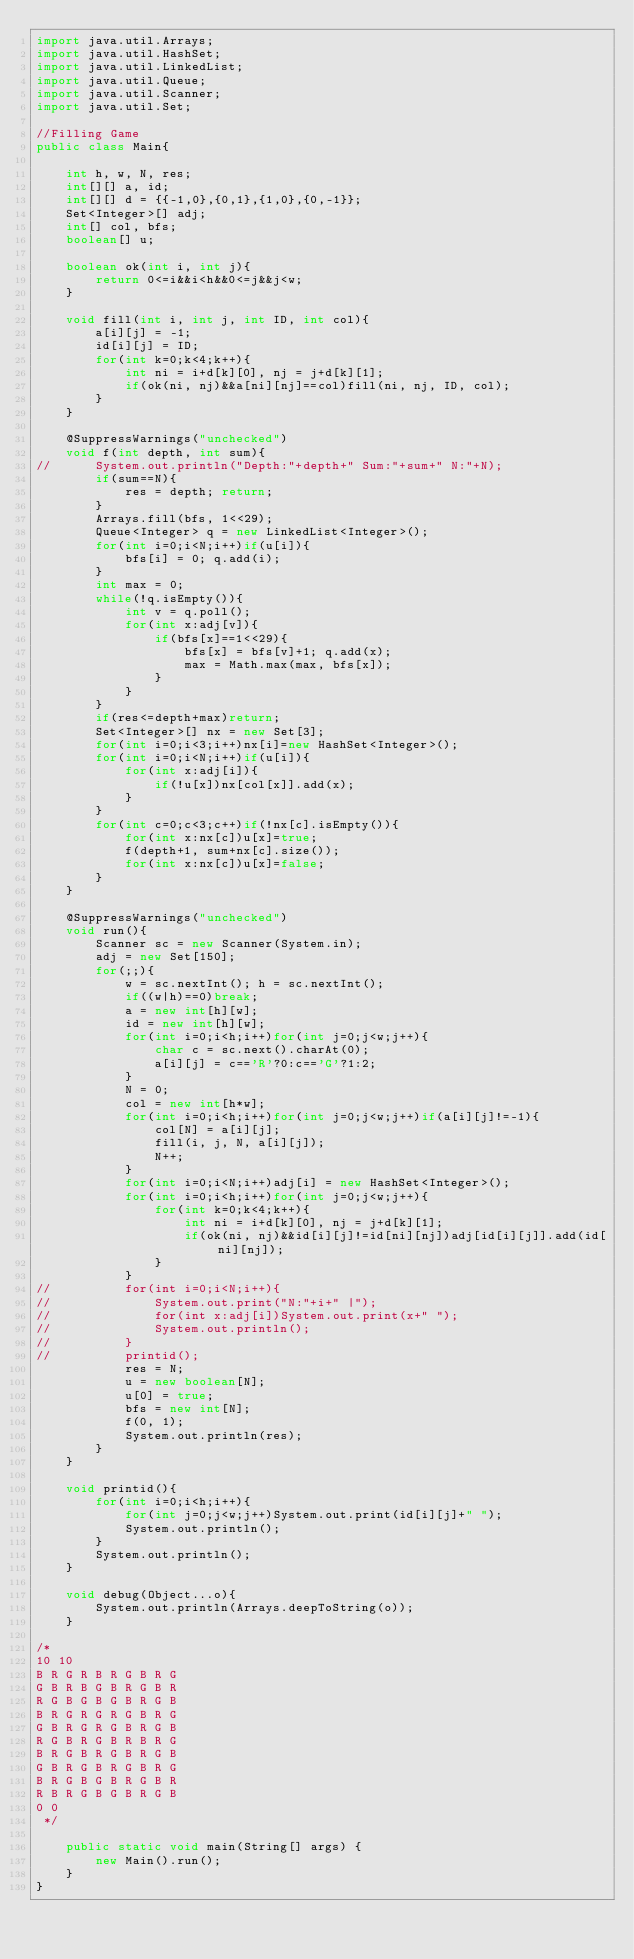<code> <loc_0><loc_0><loc_500><loc_500><_Java_>import java.util.Arrays;
import java.util.HashSet;
import java.util.LinkedList;
import java.util.Queue;
import java.util.Scanner;
import java.util.Set;

//Filling Game
public class Main{
	
	int h, w, N, res;
	int[][] a, id;
	int[][] d = {{-1,0},{0,1},{1,0},{0,-1}};
	Set<Integer>[] adj;
	int[] col, bfs;
	boolean[] u;
	
	boolean ok(int i, int j){
		return 0<=i&&i<h&&0<=j&&j<w;
	}
	
	void fill(int i, int j, int ID, int col){
		a[i][j] = -1;
		id[i][j] = ID;
		for(int k=0;k<4;k++){
			int ni = i+d[k][0], nj = j+d[k][1];
			if(ok(ni, nj)&&a[ni][nj]==col)fill(ni, nj, ID, col);
		}
	}
	
	@SuppressWarnings("unchecked")
	void f(int depth, int sum){
//		System.out.println("Depth:"+depth+" Sum:"+sum+" N:"+N);
		if(sum==N){
			res = depth; return;
		}
		Arrays.fill(bfs, 1<<29);
		Queue<Integer> q = new LinkedList<Integer>();
		for(int i=0;i<N;i++)if(u[i]){
			bfs[i] = 0; q.add(i);
		}
		int max = 0;
		while(!q.isEmpty()){
			int v = q.poll();
			for(int x:adj[v]){
				if(bfs[x]==1<<29){
					bfs[x] = bfs[v]+1; q.add(x);
					max = Math.max(max, bfs[x]);
				}
			}
		}
		if(res<=depth+max)return;
		Set<Integer>[] nx = new Set[3];
		for(int i=0;i<3;i++)nx[i]=new HashSet<Integer>();
		for(int i=0;i<N;i++)if(u[i]){
			for(int x:adj[i]){
				if(!u[x])nx[col[x]].add(x);
			}
		}
		for(int c=0;c<3;c++)if(!nx[c].isEmpty()){
			for(int x:nx[c])u[x]=true;
			f(depth+1, sum+nx[c].size());
			for(int x:nx[c])u[x]=false;
		}
	}
	
	@SuppressWarnings("unchecked")
	void run(){
		Scanner sc = new Scanner(System.in);
		adj = new Set[150];
		for(;;){
			w = sc.nextInt(); h = sc.nextInt();
			if((w|h)==0)break;
			a = new int[h][w];
			id = new int[h][w];
			for(int i=0;i<h;i++)for(int j=0;j<w;j++){
				char c = sc.next().charAt(0);
				a[i][j] = c=='R'?0:c=='G'?1:2;
			}
			N = 0;
			col = new int[h*w];
			for(int i=0;i<h;i++)for(int j=0;j<w;j++)if(a[i][j]!=-1){
				col[N] = a[i][j];
				fill(i, j, N, a[i][j]);
				N++;
			}
			for(int i=0;i<N;i++)adj[i] = new HashSet<Integer>();
			for(int i=0;i<h;i++)for(int j=0;j<w;j++){
				for(int k=0;k<4;k++){
					int ni = i+d[k][0], nj = j+d[k][1];
					if(ok(ni, nj)&&id[i][j]!=id[ni][nj])adj[id[i][j]].add(id[ni][nj]);
				}
			}
//			for(int i=0;i<N;i++){
//				System.out.print("N:"+i+" |");
//				for(int x:adj[i])System.out.print(x+" ");
//				System.out.println();
//			}
//			printid();
			res = N;
			u = new boolean[N];
			u[0] = true;
			bfs = new int[N];
			f(0, 1);
			System.out.println(res);
		}
	}
	
	void printid(){
		for(int i=0;i<h;i++){
			for(int j=0;j<w;j++)System.out.print(id[i][j]+" ");
			System.out.println();
		}
		System.out.println();
	}
	
	void debug(Object...o){
		System.out.println(Arrays.deepToString(o));
	}
	
/*
10 10
B R G R B R G B R G
G B R B G B R G B R
R G B G B G B R G B
B R G R G R G B R G
G B R G R G B R G B
R G B R G B R B R G
B R G B R G B R G B
G B R G B R G B R G
B R G B G B R G B R
R B R G B G B R G B
0 0
 */
	
	public static void main(String[] args) {
		new Main().run();
	}
}</code> 